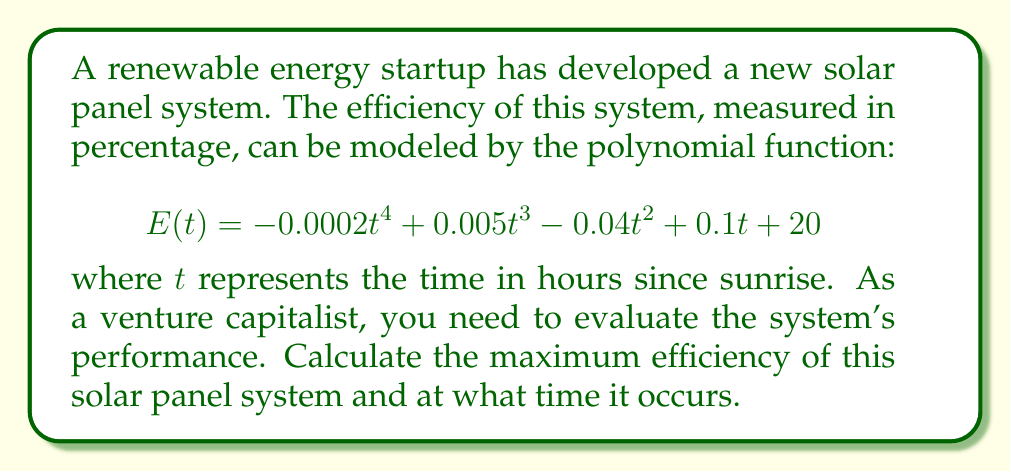Solve this math problem. To find the maximum efficiency and the time it occurs, we need to follow these steps:

1) The maximum efficiency will occur at a critical point of the function $E(t)$. To find critical points, we need to calculate the derivative and set it equal to zero.

2) The derivative of $E(t)$ is:
   $$E'(t) = -0.0008t^3 + 0.015t^2 - 0.08t + 0.1$$

3) Set $E'(t) = 0$ and solve for $t$:
   $$-0.0008t^3 + 0.015t^2 - 0.08t + 0.1 = 0$$

4) This cubic equation is difficult to solve by hand. Using a numerical method or graphing calculator, we find the roots are approximately:
   $t \approx 1.25, 5.83, 11.67$

5) The domain of our function is realistically $[0, 24]$ as it represents hours in a day. So all these critical points are within our domain.

6) To determine which critical point gives the maximum efficiency, we need to evaluate $E(t)$ at each point and at the endpoints of our domain:

   $E(0) = 20$
   $E(1.25) \approx 20.11$
   $E(5.83) \approx 20.39$
   $E(11.67) \approx 19.17$
   $E(24) \approx -29.75$

7) The maximum value occurs at $t \approx 5.83$ hours after sunrise.

8) Therefore, the maximum efficiency is $E(5.83) \approx 20.39\%$.
Answer: The maximum efficiency of the solar panel system is approximately 20.39%, occurring about 5.83 hours after sunrise. 